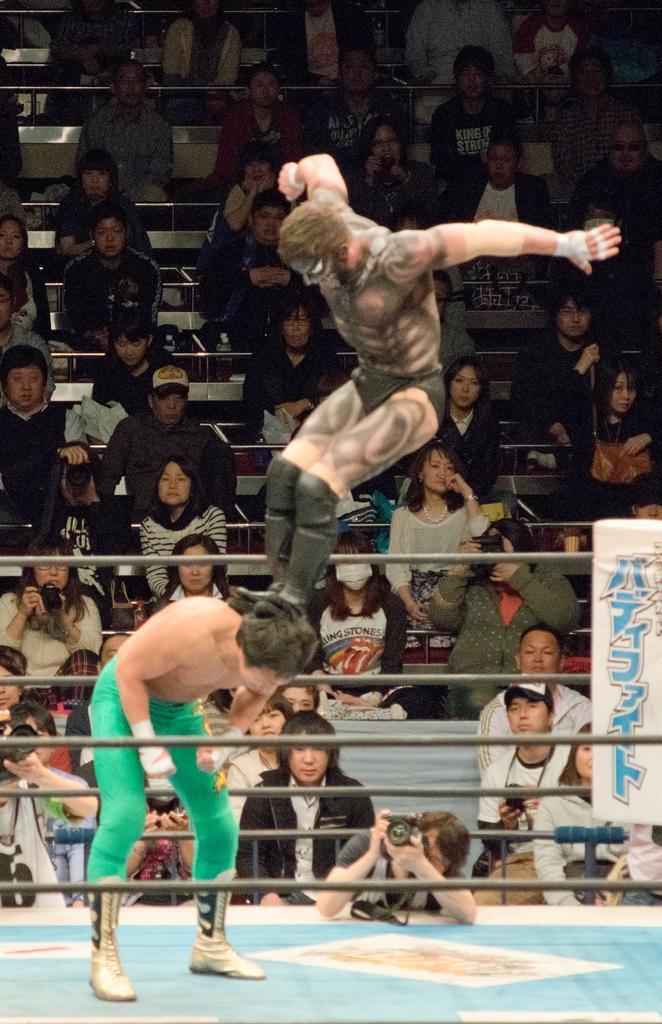Could you give a brief overview of what you see in this image? In the center of the image we can see a man jumping. On the left there is a man standing. On the right there is a board. We can see ropes. In the background there are people sitting and some of them are holding cameras. 